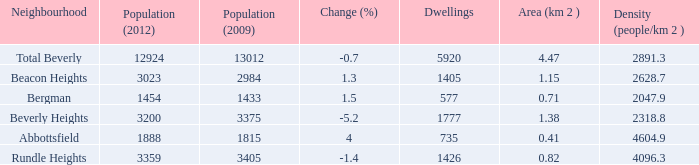How many Dwellings does Beverly Heights have that have a change percent larger than -5.2? None. 